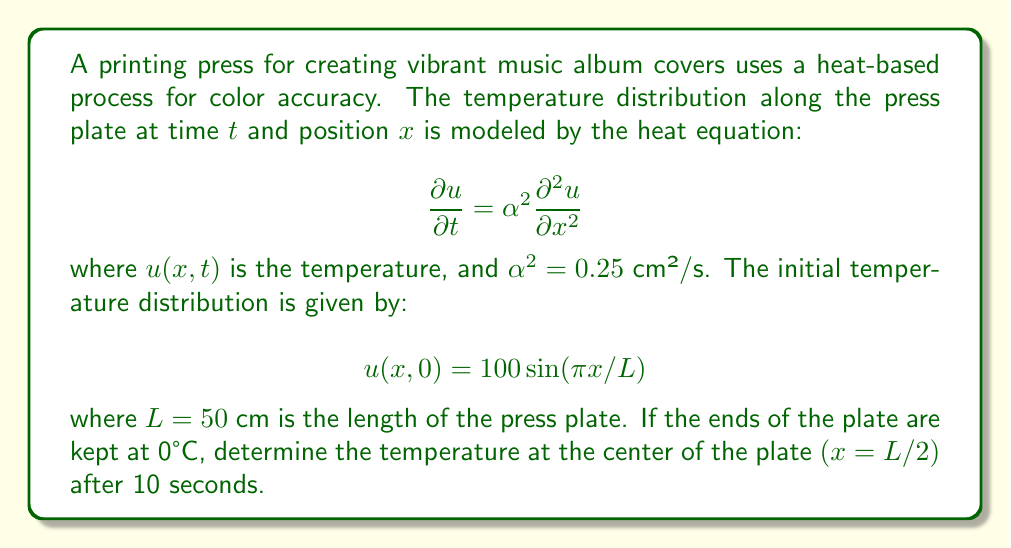Could you help me with this problem? To solve this heat equation problem, we'll follow these steps:

1) The general solution for the heat equation with the given boundary conditions is:

   $$u(x,t) = \sum_{n=1}^{\infty} B_n \sin(\frac{n\pi x}{L}) e^{-\alpha^2 (\frac{n\pi}{L})^2 t}$$

2) Given the initial condition, we can see that only the first term $(n=1)$ of the series is non-zero, and $B_1 = 100$. So our solution simplifies to:

   $$u(x,t) = 100 \sin(\frac{\pi x}{L}) e^{-\alpha^2 (\frac{\pi}{L})^2 t}$$

3) We need to find $u(L/2, 10)$. Let's substitute the known values:
   - $x = L/2 = 25$ cm
   - $t = 10$ s
   - $L = 50$ cm
   - $\alpha^2 = 0.25$ cm²/s

4) First, let's calculate the sin term:

   $$\sin(\frac{\pi x}{L}) = \sin(\frac{\pi 25}{50}) = \sin(\frac{\pi}{2}) = 1$$

5) Now, let's calculate the exponent:

   $$-\alpha^2 (\frac{\pi}{L})^2 t = -0.25 (\frac{\pi}{50})^2 10 = -0.00098696$$

6) Therefore, the temperature at the center of the plate after 10 seconds is:

   $$u(25, 10) = 100 \cdot 1 \cdot e^{-0.00098696} \approx 99.90°C$$
Answer: 99.90°C 